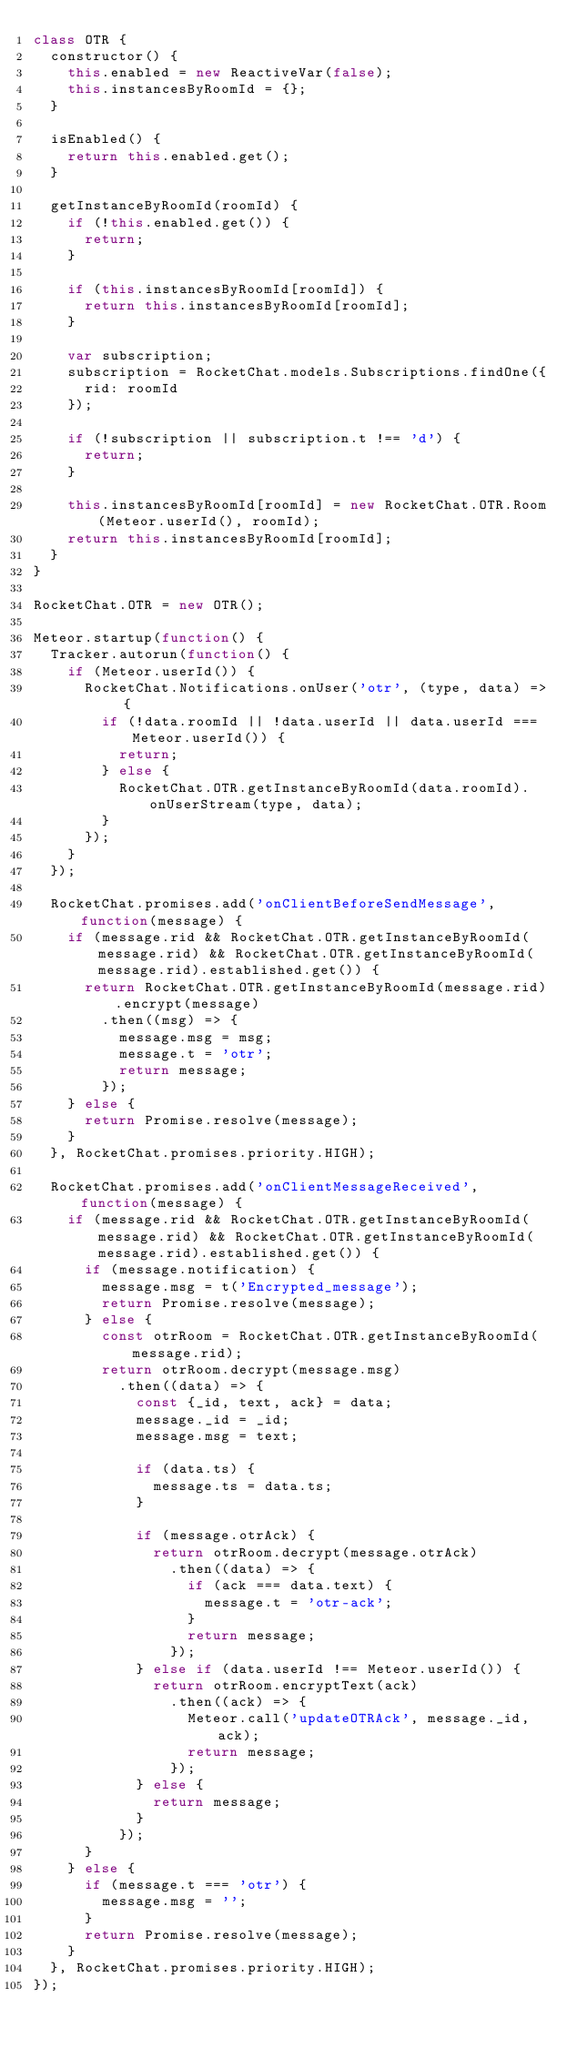<code> <loc_0><loc_0><loc_500><loc_500><_JavaScript_>class OTR {
	constructor() {
		this.enabled = new ReactiveVar(false);
		this.instancesByRoomId = {};
	}

	isEnabled() {
		return this.enabled.get();
	}

	getInstanceByRoomId(roomId) {
		if (!this.enabled.get()) {
			return;
		}

		if (this.instancesByRoomId[roomId]) {
			return this.instancesByRoomId[roomId];
		}

		var subscription;
		subscription = RocketChat.models.Subscriptions.findOne({
			rid: roomId
		});

		if (!subscription || subscription.t !== 'd') {
			return;
		}

		this.instancesByRoomId[roomId] = new RocketChat.OTR.Room(Meteor.userId(), roomId);
		return this.instancesByRoomId[roomId];
	}
}

RocketChat.OTR = new OTR();

Meteor.startup(function() {
	Tracker.autorun(function() {
		if (Meteor.userId()) {
			RocketChat.Notifications.onUser('otr', (type, data) => {
				if (!data.roomId || !data.userId || data.userId === Meteor.userId()) {
					return;
				} else {
					RocketChat.OTR.getInstanceByRoomId(data.roomId).onUserStream(type, data);
				}
			});
		}
	});

	RocketChat.promises.add('onClientBeforeSendMessage', function(message) {
		if (message.rid && RocketChat.OTR.getInstanceByRoomId(message.rid) && RocketChat.OTR.getInstanceByRoomId(message.rid).established.get()) {
			return RocketChat.OTR.getInstanceByRoomId(message.rid).encrypt(message)
				.then((msg) => {
					message.msg = msg;
					message.t = 'otr';
					return message;
				});
		} else {
			return Promise.resolve(message);
		}
	}, RocketChat.promises.priority.HIGH);

	RocketChat.promises.add('onClientMessageReceived', function(message) {
		if (message.rid && RocketChat.OTR.getInstanceByRoomId(message.rid) && RocketChat.OTR.getInstanceByRoomId(message.rid).established.get()) {
			if (message.notification) {
				message.msg = t('Encrypted_message');
				return Promise.resolve(message);
			} else {
				const otrRoom = RocketChat.OTR.getInstanceByRoomId(message.rid);
				return otrRoom.decrypt(message.msg)
					.then((data) => {
						const {_id, text, ack} = data;
						message._id = _id;
						message.msg = text;

						if (data.ts) {
							message.ts = data.ts;
						}

						if (message.otrAck) {
							return otrRoom.decrypt(message.otrAck)
								.then((data) => {
									if (ack === data.text) {
										message.t = 'otr-ack';
									}
									return message;
								});
						} else if (data.userId !== Meteor.userId()) {
							return otrRoom.encryptText(ack)
								.then((ack) => {
									Meteor.call('updateOTRAck', message._id, ack);
									return message;
								});
						} else {
							return message;
						}
					});
			}
		} else {
			if (message.t === 'otr') {
				message.msg = '';
			}
			return Promise.resolve(message);
		}
	}, RocketChat.promises.priority.HIGH);
});
</code> 